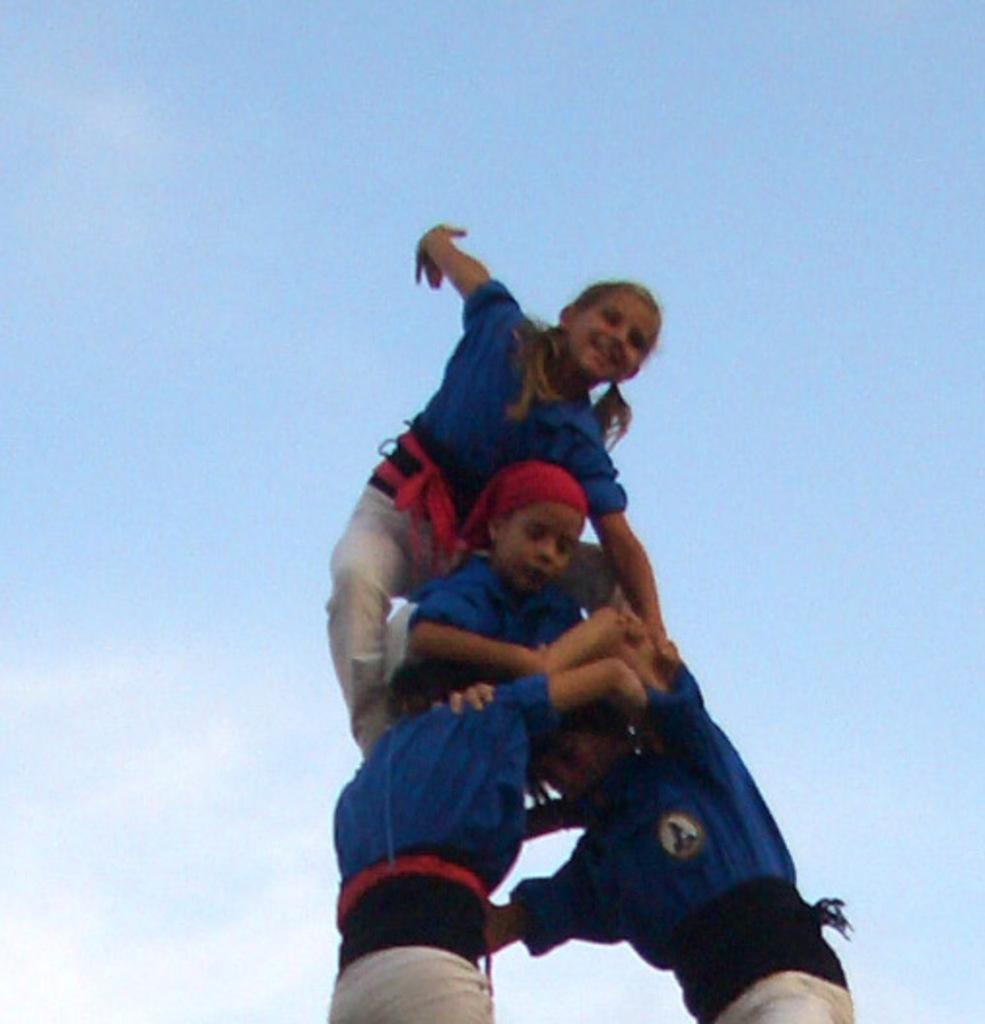In one or two sentences, can you explain what this image depicts? In this image we can see many people. There is a blue sky in the image. 